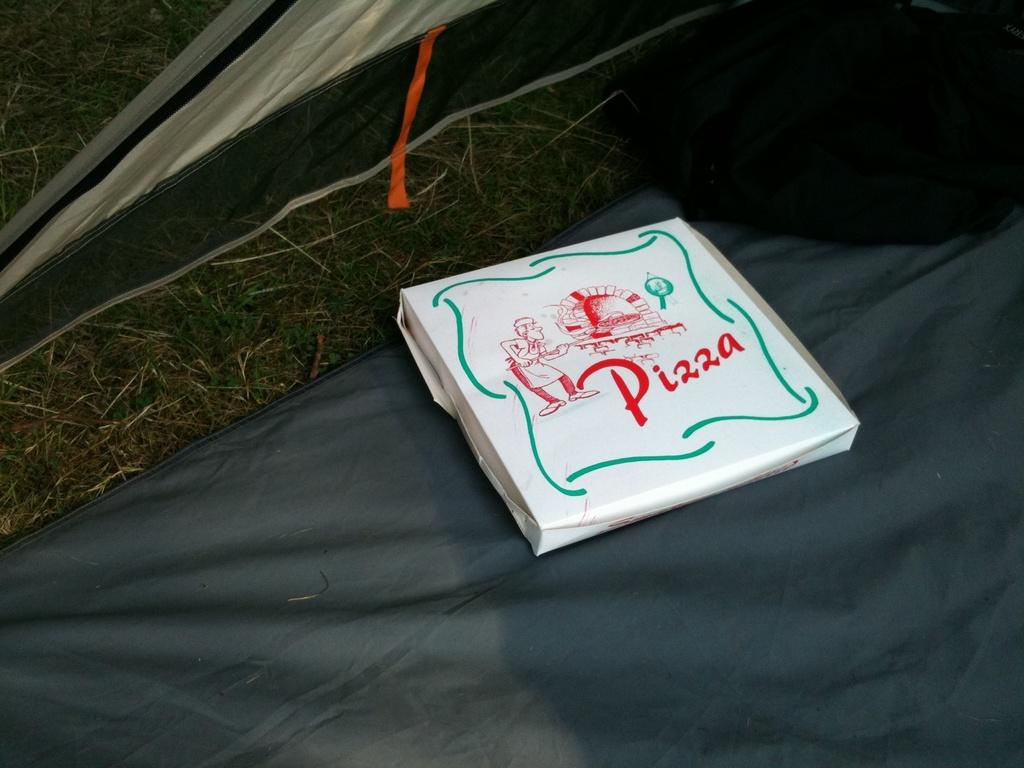What is the main object in the image? There is a cardboard carton in the image. Where is the cardboard carton located? The cardboard carton is placed on the ground. What type of debt is associated with the cardboard carton in the image? There is no mention of debt in the image, and the cardboard carton is not associated with any financial obligations. 